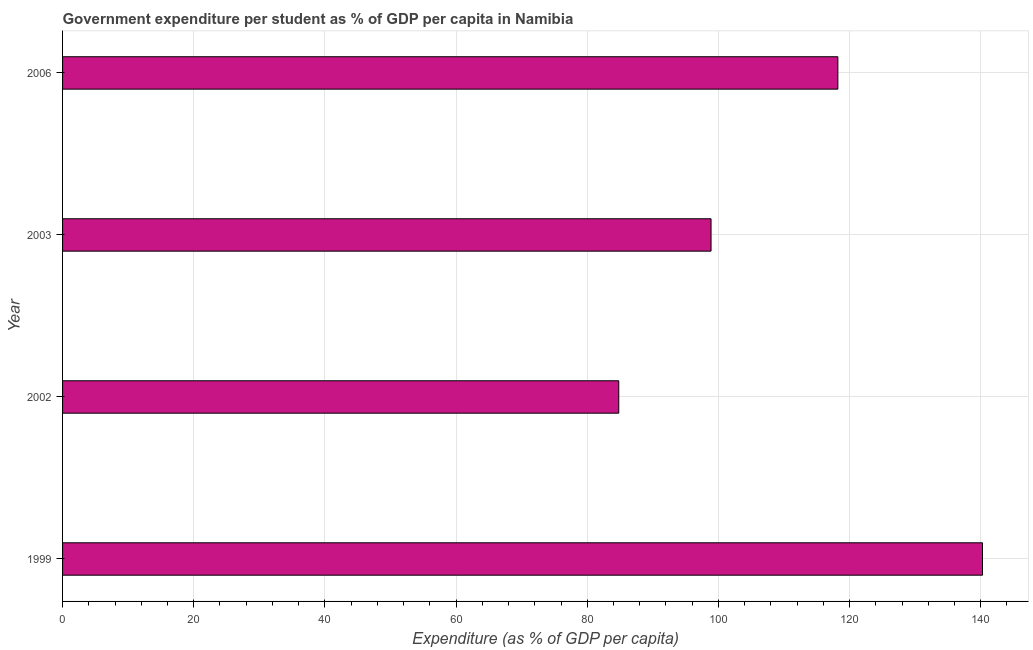Does the graph contain grids?
Give a very brief answer. Yes. What is the title of the graph?
Provide a succinct answer. Government expenditure per student as % of GDP per capita in Namibia. What is the label or title of the X-axis?
Ensure brevity in your answer.  Expenditure (as % of GDP per capita). What is the label or title of the Y-axis?
Offer a terse response. Year. What is the government expenditure per student in 1999?
Provide a short and direct response. 140.27. Across all years, what is the maximum government expenditure per student?
Your answer should be compact. 140.27. Across all years, what is the minimum government expenditure per student?
Ensure brevity in your answer.  84.81. In which year was the government expenditure per student maximum?
Keep it short and to the point. 1999. What is the sum of the government expenditure per student?
Ensure brevity in your answer.  442.17. What is the difference between the government expenditure per student in 2002 and 2003?
Make the answer very short. -14.07. What is the average government expenditure per student per year?
Keep it short and to the point. 110.54. What is the median government expenditure per student?
Make the answer very short. 108.55. In how many years, is the government expenditure per student greater than 44 %?
Your answer should be compact. 4. What is the ratio of the government expenditure per student in 1999 to that in 2006?
Your answer should be compact. 1.19. Is the difference between the government expenditure per student in 1999 and 2006 greater than the difference between any two years?
Offer a very short reply. No. What is the difference between the highest and the second highest government expenditure per student?
Provide a short and direct response. 22.05. What is the difference between the highest and the lowest government expenditure per student?
Offer a terse response. 55.46. How many years are there in the graph?
Your response must be concise. 4. What is the Expenditure (as % of GDP per capita) of 1999?
Provide a short and direct response. 140.27. What is the Expenditure (as % of GDP per capita) of 2002?
Provide a succinct answer. 84.81. What is the Expenditure (as % of GDP per capita) in 2003?
Provide a short and direct response. 98.88. What is the Expenditure (as % of GDP per capita) in 2006?
Offer a very short reply. 118.22. What is the difference between the Expenditure (as % of GDP per capita) in 1999 and 2002?
Your answer should be very brief. 55.46. What is the difference between the Expenditure (as % of GDP per capita) in 1999 and 2003?
Offer a terse response. 41.39. What is the difference between the Expenditure (as % of GDP per capita) in 1999 and 2006?
Your response must be concise. 22.05. What is the difference between the Expenditure (as % of GDP per capita) in 2002 and 2003?
Offer a very short reply. -14.07. What is the difference between the Expenditure (as % of GDP per capita) in 2002 and 2006?
Give a very brief answer. -33.41. What is the difference between the Expenditure (as % of GDP per capita) in 2003 and 2006?
Ensure brevity in your answer.  -19.34. What is the ratio of the Expenditure (as % of GDP per capita) in 1999 to that in 2002?
Offer a terse response. 1.65. What is the ratio of the Expenditure (as % of GDP per capita) in 1999 to that in 2003?
Your answer should be compact. 1.42. What is the ratio of the Expenditure (as % of GDP per capita) in 1999 to that in 2006?
Provide a succinct answer. 1.19. What is the ratio of the Expenditure (as % of GDP per capita) in 2002 to that in 2003?
Your answer should be very brief. 0.86. What is the ratio of the Expenditure (as % of GDP per capita) in 2002 to that in 2006?
Your response must be concise. 0.72. What is the ratio of the Expenditure (as % of GDP per capita) in 2003 to that in 2006?
Make the answer very short. 0.84. 